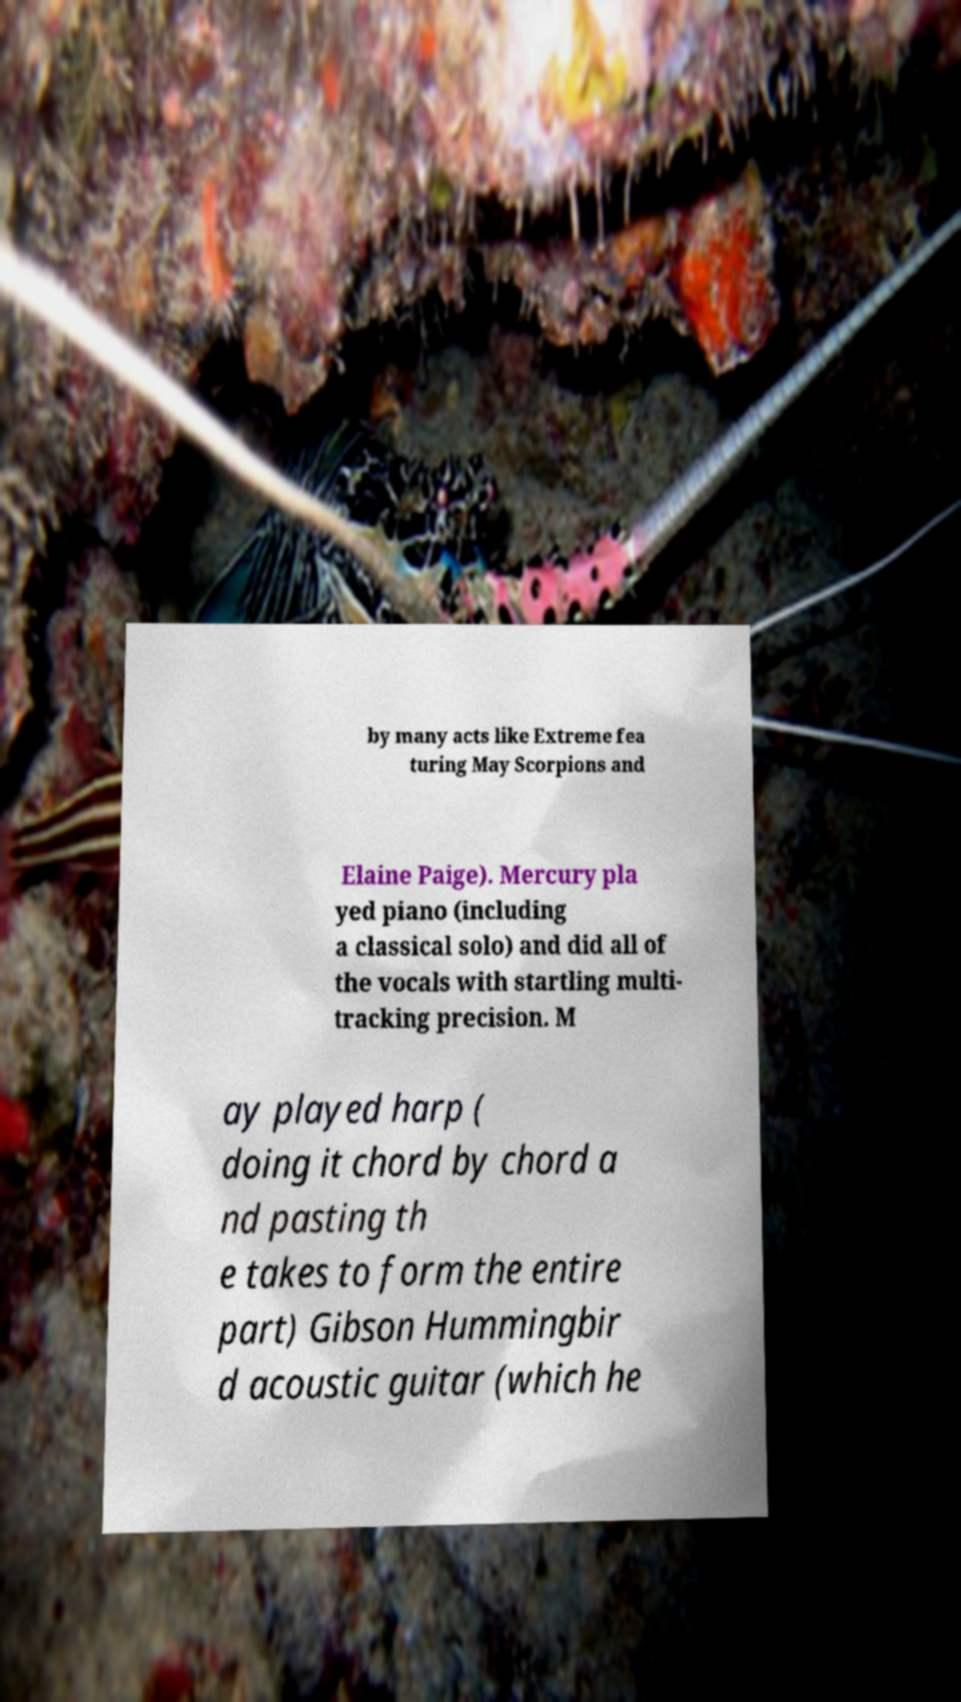There's text embedded in this image that I need extracted. Can you transcribe it verbatim? by many acts like Extreme fea turing May Scorpions and Elaine Paige). Mercury pla yed piano (including a classical solo) and did all of the vocals with startling multi- tracking precision. M ay played harp ( doing it chord by chord a nd pasting th e takes to form the entire part) Gibson Hummingbir d acoustic guitar (which he 